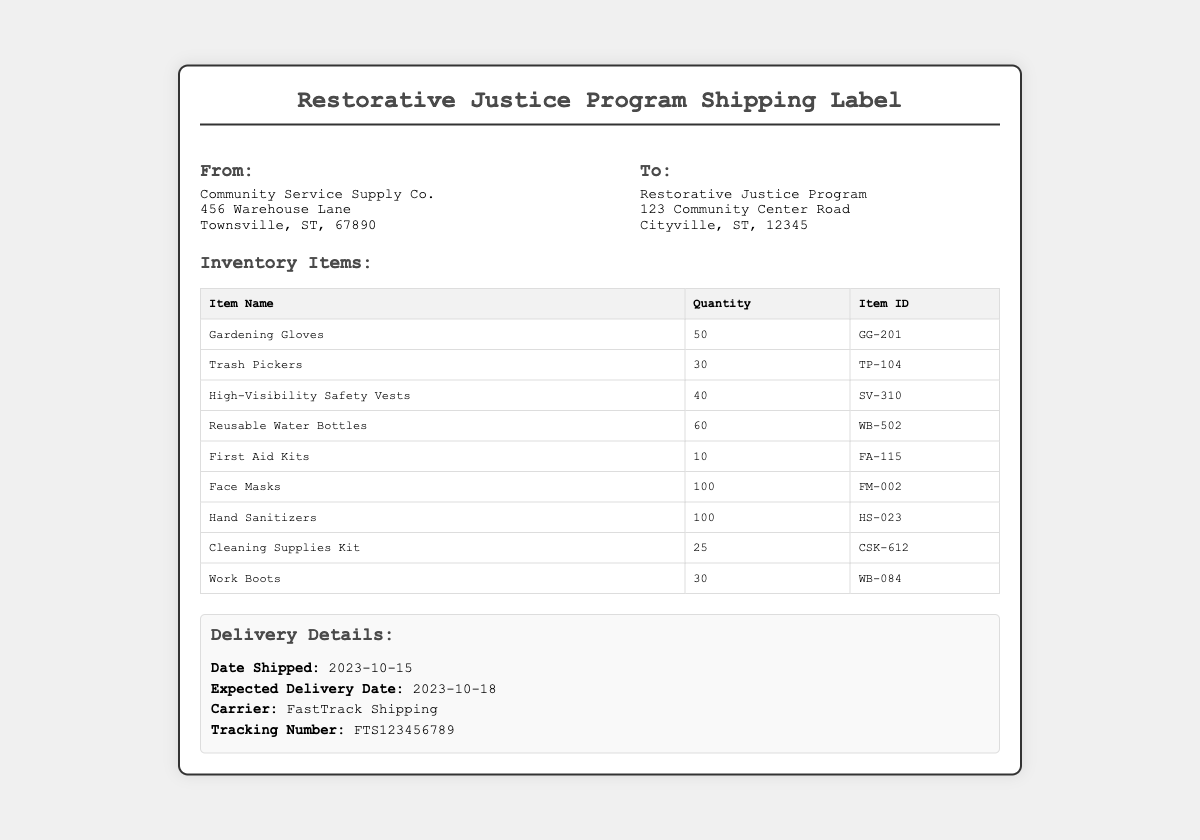What is the shipping date? The shipping date is stated clearly in the delivery details section of the document.
Answer: 2023-10-15 What is the expected delivery date? The expected delivery date is provided alongside the shipping date, allowing for easy reference.
Answer: 2023-10-18 How many gardening gloves are included? The quantity of gardening gloves is listed in the inventory items table.
Answer: 50 What is the item ID for the first aid kit? The item ID is included in the inventory table under the respective item.
Answer: FA-115 Who is the carrier for the shipment? The carrier name is mentioned in the delivery details, indicating who will deliver the supplies.
Answer: FastTrack Shipping How many face masks are there? The quantity of face masks is detailed in the inventory items, which can be found in the table.
Answer: 100 What is the address of the sender? The sender's address can be found in the "From" section of the document.
Answer: Community Service Supply Co., 456 Warehouse Lane, Townsville, ST, 67890 How many items are in the inventory? The inventory section provides a list of items, and counting the rows will give the total number of items.
Answer: 9 What is the tracking number for the shipment? The tracking number is provided in the delivery details, essential for monitoring the shipment.
Answer: FTS123456789 